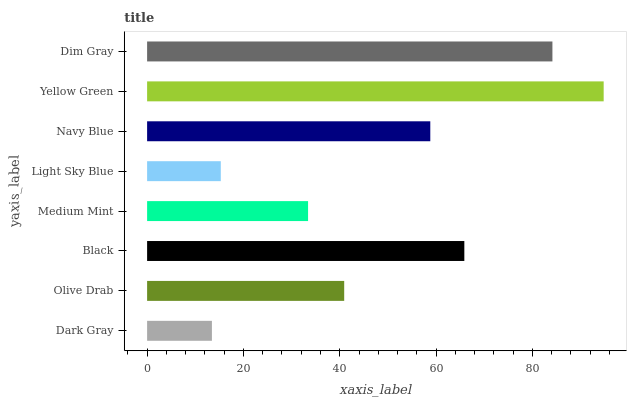Is Dark Gray the minimum?
Answer yes or no. Yes. Is Yellow Green the maximum?
Answer yes or no. Yes. Is Olive Drab the minimum?
Answer yes or no. No. Is Olive Drab the maximum?
Answer yes or no. No. Is Olive Drab greater than Dark Gray?
Answer yes or no. Yes. Is Dark Gray less than Olive Drab?
Answer yes or no. Yes. Is Dark Gray greater than Olive Drab?
Answer yes or no. No. Is Olive Drab less than Dark Gray?
Answer yes or no. No. Is Navy Blue the high median?
Answer yes or no. Yes. Is Olive Drab the low median?
Answer yes or no. Yes. Is Yellow Green the high median?
Answer yes or no. No. Is Light Sky Blue the low median?
Answer yes or no. No. 